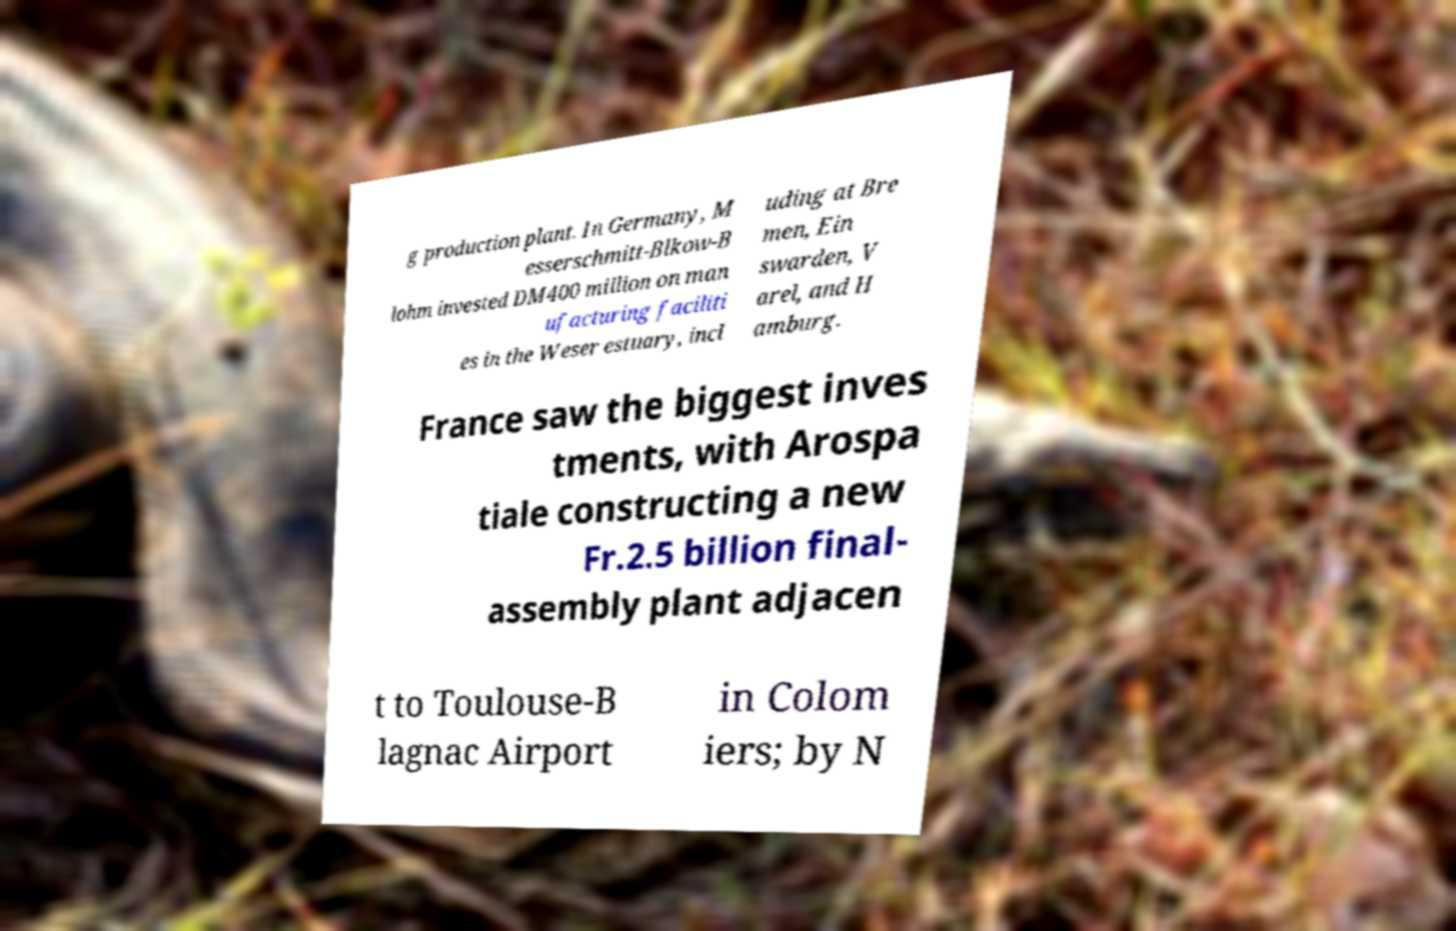Could you extract and type out the text from this image? g production plant. In Germany, M esserschmitt-Blkow-B lohm invested DM400 million on man ufacturing faciliti es in the Weser estuary, incl uding at Bre men, Ein swarden, V arel, and H amburg. France saw the biggest inves tments, with Arospa tiale constructing a new Fr.2.5 billion final- assembly plant adjacen t to Toulouse-B lagnac Airport in Colom iers; by N 